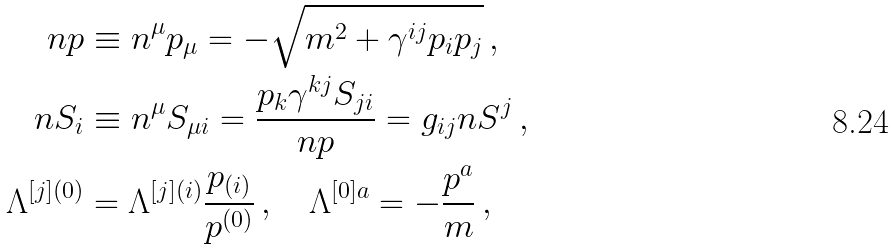Convert formula to latex. <formula><loc_0><loc_0><loc_500><loc_500>n p & \equiv n ^ { \mu } p _ { \mu } = - \sqrt { m ^ { 2 } + \gamma ^ { i j } p _ { i } p _ { j } } \, , \\ n S _ { i } & \equiv n ^ { \mu } S _ { \mu i } = \frac { p _ { k } \gamma ^ { k j } S _ { j i } } { n p } = g _ { i j } n S ^ { j } \, , \\ \Lambda ^ { [ j ] ( 0 ) } & = \Lambda ^ { [ j ] ( i ) } \frac { p _ { ( i ) } } { p ^ { ( 0 ) } } \, , \quad \Lambda ^ { [ 0 ] a } = - \frac { p ^ { a } } { m } \, ,</formula> 